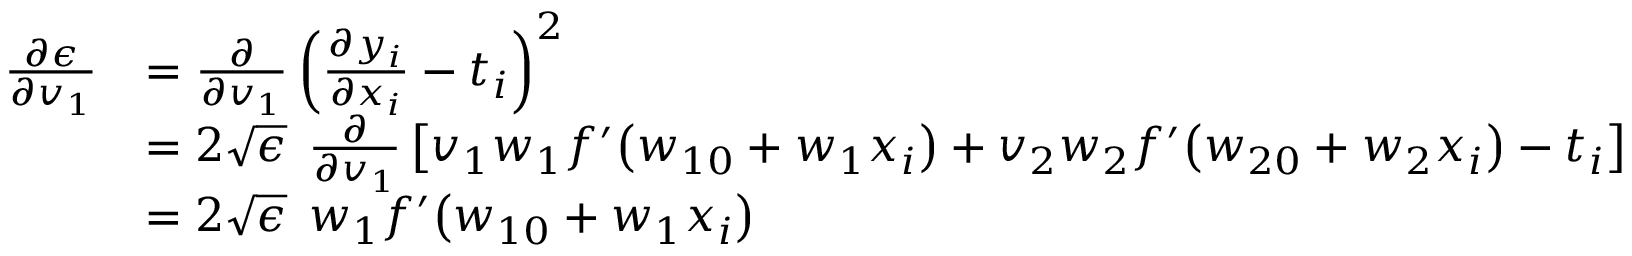<formula> <loc_0><loc_0><loc_500><loc_500>\begin{array} { r l } { \frac { \partial \epsilon } { \partial v _ { 1 } } } & { = \frac { \partial } { \partial v _ { 1 } } \left ( \frac { \partial y _ { i } } { \partial x _ { i } } - t _ { i } \right ) ^ { 2 } } \\ & { = 2 \sqrt { \epsilon } \, \frac { \partial } { \partial v _ { 1 } } \left [ v _ { 1 } w _ { 1 } f ^ { \prime } \left ( w _ { 1 0 } + w _ { 1 } x _ { i } \right ) + v _ { 2 } w _ { 2 } f ^ { \prime } \left ( w _ { 2 0 } + w _ { 2 } x _ { i } \right ) - t _ { i } \right ] } \\ & { = 2 \sqrt { \epsilon } \, w _ { 1 } f ^ { \prime } \left ( w _ { 1 0 } + w _ { 1 } x _ { i } \right ) } \end{array}</formula> 